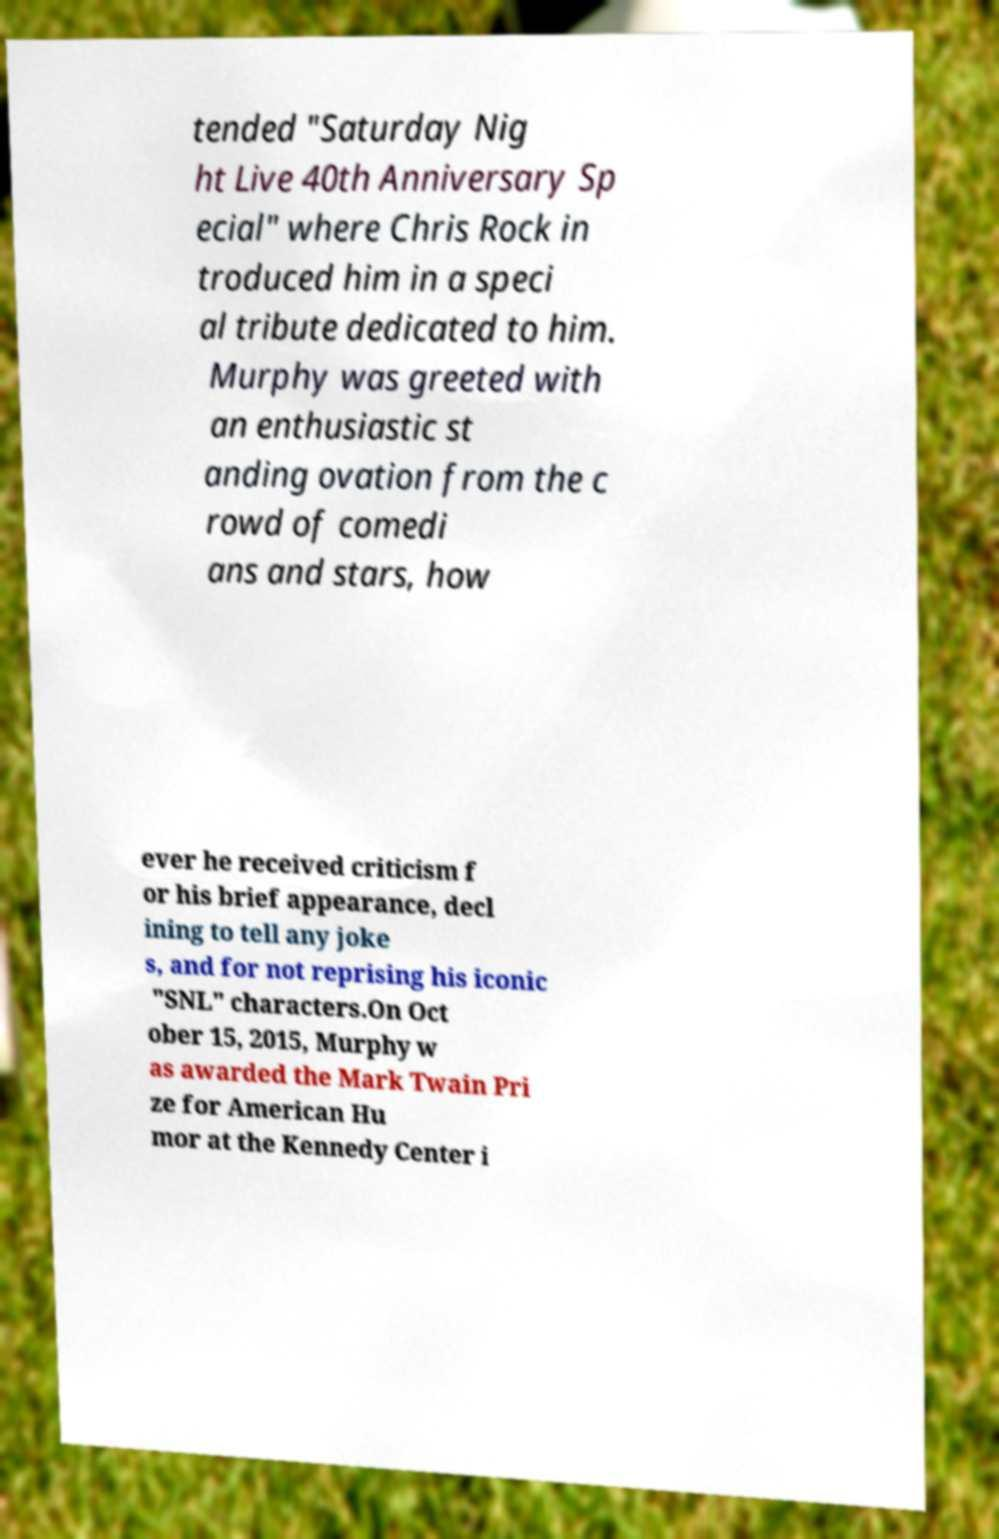Can you read and provide the text displayed in the image?This photo seems to have some interesting text. Can you extract and type it out for me? tended "Saturday Nig ht Live 40th Anniversary Sp ecial" where Chris Rock in troduced him in a speci al tribute dedicated to him. Murphy was greeted with an enthusiastic st anding ovation from the c rowd of comedi ans and stars, how ever he received criticism f or his brief appearance, decl ining to tell any joke s, and for not reprising his iconic "SNL" characters.On Oct ober 15, 2015, Murphy w as awarded the Mark Twain Pri ze for American Hu mor at the Kennedy Center i 